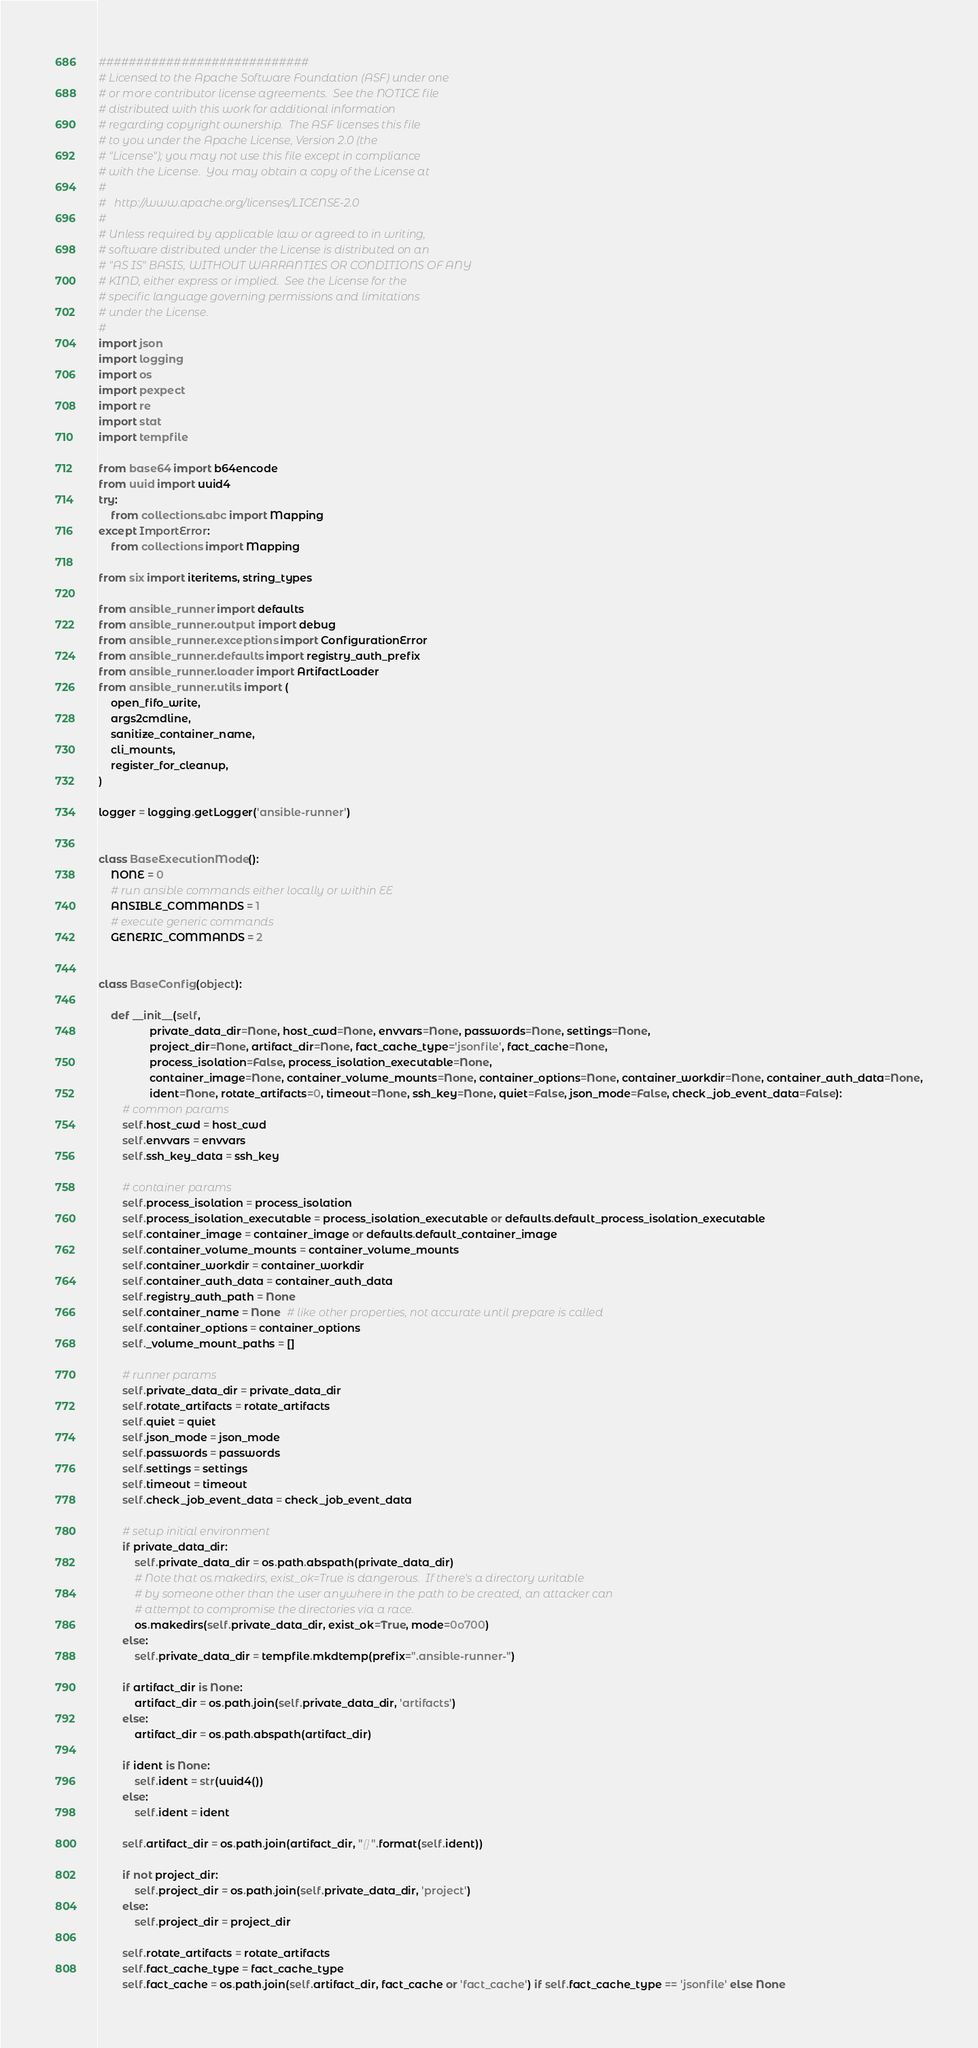<code> <loc_0><loc_0><loc_500><loc_500><_Python_>############################
# Licensed to the Apache Software Foundation (ASF) under one
# or more contributor license agreements.  See the NOTICE file
# distributed with this work for additional information
# regarding copyright ownership.  The ASF licenses this file
# to you under the Apache License, Version 2.0 (the
# "License"); you may not use this file except in compliance
# with the License.  You may obtain a copy of the License at
#
#   http://www.apache.org/licenses/LICENSE-2.0
#
# Unless required by applicable law or agreed to in writing,
# software distributed under the License is distributed on an
# "AS IS" BASIS, WITHOUT WARRANTIES OR CONDITIONS OF ANY
# KIND, either express or implied.  See the License for the
# specific language governing permissions and limitations
# under the License.
#
import json
import logging
import os
import pexpect
import re
import stat
import tempfile

from base64 import b64encode
from uuid import uuid4
try:
    from collections.abc import Mapping
except ImportError:
    from collections import Mapping

from six import iteritems, string_types

from ansible_runner import defaults
from ansible_runner.output import debug
from ansible_runner.exceptions import ConfigurationError
from ansible_runner.defaults import registry_auth_prefix
from ansible_runner.loader import ArtifactLoader
from ansible_runner.utils import (
    open_fifo_write,
    args2cmdline,
    sanitize_container_name,
    cli_mounts,
    register_for_cleanup,
)

logger = logging.getLogger('ansible-runner')


class BaseExecutionMode():
    NONE = 0
    # run ansible commands either locally or within EE
    ANSIBLE_COMMANDS = 1
    # execute generic commands
    GENERIC_COMMANDS = 2


class BaseConfig(object):

    def __init__(self,
                 private_data_dir=None, host_cwd=None, envvars=None, passwords=None, settings=None,
                 project_dir=None, artifact_dir=None, fact_cache_type='jsonfile', fact_cache=None,
                 process_isolation=False, process_isolation_executable=None,
                 container_image=None, container_volume_mounts=None, container_options=None, container_workdir=None, container_auth_data=None,
                 ident=None, rotate_artifacts=0, timeout=None, ssh_key=None, quiet=False, json_mode=False, check_job_event_data=False):
        # common params
        self.host_cwd = host_cwd
        self.envvars = envvars
        self.ssh_key_data = ssh_key

        # container params
        self.process_isolation = process_isolation
        self.process_isolation_executable = process_isolation_executable or defaults.default_process_isolation_executable
        self.container_image = container_image or defaults.default_container_image
        self.container_volume_mounts = container_volume_mounts
        self.container_workdir = container_workdir
        self.container_auth_data = container_auth_data
        self.registry_auth_path = None
        self.container_name = None  # like other properties, not accurate until prepare is called
        self.container_options = container_options
        self._volume_mount_paths = []

        # runner params
        self.private_data_dir = private_data_dir
        self.rotate_artifacts = rotate_artifacts
        self.quiet = quiet
        self.json_mode = json_mode
        self.passwords = passwords
        self.settings = settings
        self.timeout = timeout
        self.check_job_event_data = check_job_event_data

        # setup initial environment
        if private_data_dir:
            self.private_data_dir = os.path.abspath(private_data_dir)
            # Note that os.makedirs, exist_ok=True is dangerous.  If there's a directory writable
            # by someone other than the user anywhere in the path to be created, an attacker can
            # attempt to compromise the directories via a race.
            os.makedirs(self.private_data_dir, exist_ok=True, mode=0o700)
        else:
            self.private_data_dir = tempfile.mkdtemp(prefix=".ansible-runner-")

        if artifact_dir is None:
            artifact_dir = os.path.join(self.private_data_dir, 'artifacts')
        else:
            artifact_dir = os.path.abspath(artifact_dir)

        if ident is None:
            self.ident = str(uuid4())
        else:
            self.ident = ident

        self.artifact_dir = os.path.join(artifact_dir, "{}".format(self.ident))

        if not project_dir:
            self.project_dir = os.path.join(self.private_data_dir, 'project')
        else:
            self.project_dir = project_dir

        self.rotate_artifacts = rotate_artifacts
        self.fact_cache_type = fact_cache_type
        self.fact_cache = os.path.join(self.artifact_dir, fact_cache or 'fact_cache') if self.fact_cache_type == 'jsonfile' else None
</code> 